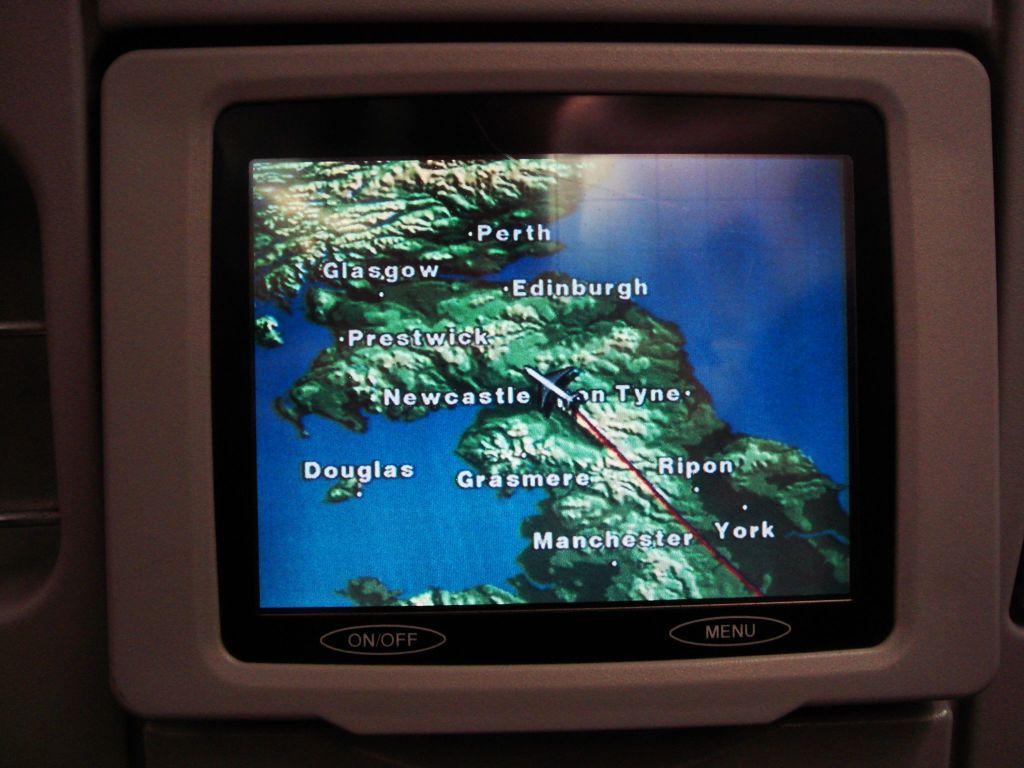What button is located on the bottom right?
Provide a short and direct response. Menu. What place is on top?
Provide a succinct answer. Perth. 